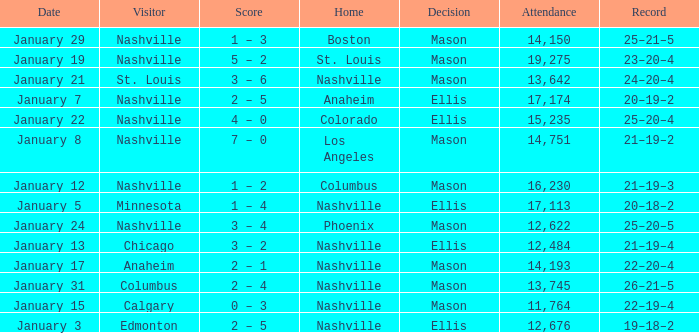On January 29, who had the decision of Mason? Nashville. 